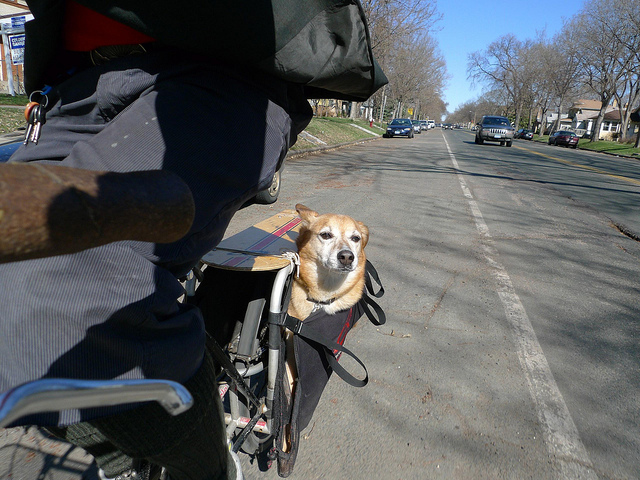Does the dog appear to be enjoying the ride? The dog's relaxed posture and alert gaze suggest that it is enjoying the ride. The open basket allows for a good view and airflow, which likely adds to the dog's comfort and enjoyment. 